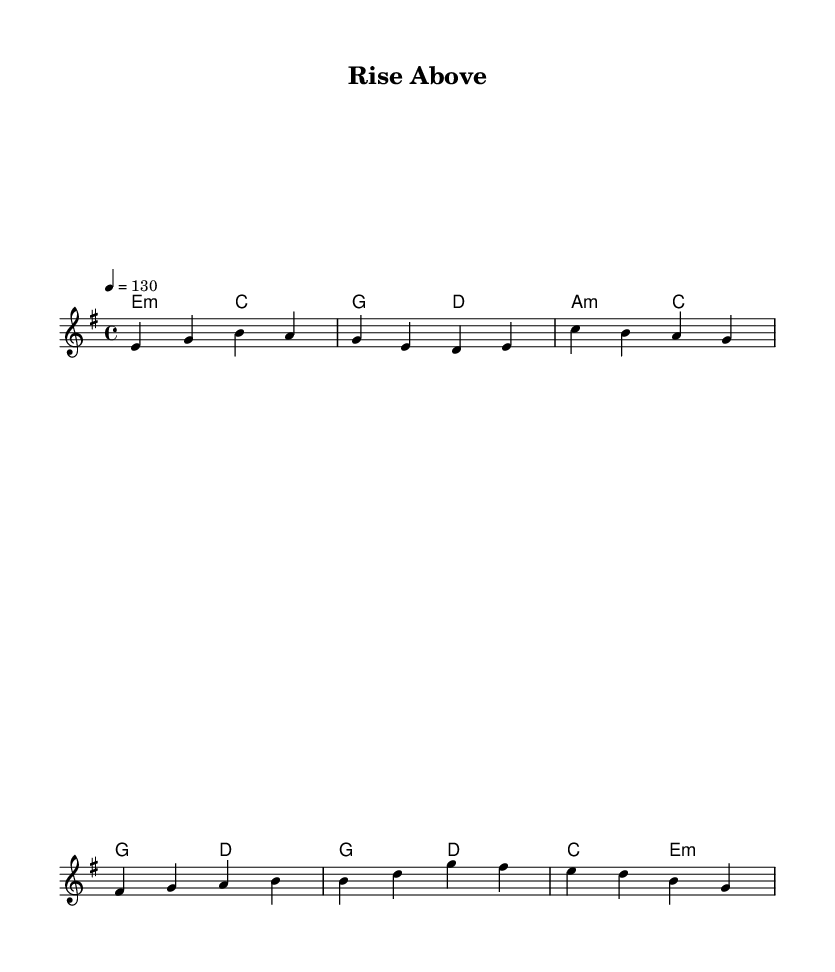What is the key signature of this music? The key signature is indicated by the presence of the E minor key label at the beginning of the score. E minor has one sharp (F#), but it is simply represented as E minor in the context of the piece.
Answer: E minor What is the time signature of this music? The time signature is found at the beginning of the score, indicated by the notation "4/4". This means there are four beats per measure, and each quarter note gets one beat.
Answer: 4/4 What is the tempo marking of this music? The tempo marking appears in the score indicated by "4 = 130", which states that there are 130 beats per minute when counted in quarter notes.
Answer: 130 How many measures are in the verse section? The verse section consists of two lines of lyrics, each with four beats. Each line represents one measure, so the total number of measures can be counted as two.
Answer: 2 What is the primary theme of the chorus? The chorus contains the lyrics "Rise above, believe in yourself," which conveys a message of self-empowerment and perseverance, summing up the overall motivational theme of the song.
Answer: Rise above, believe in yourself What type of chords are mostly used in the harmonies section? The harmonies section includes minor chords, as indicated by the presence of "m" after certain chord symbols, indicating the use of minor triads throughout.
Answer: Minor In what section do we see a change in the lyrical content? The change in lyrical content occurs as the piece transitions from the verse to the pre-chorus. The pre-chorus introduces new lyrics that build anticipation for the chorus.
Answer: From verse to pre-chorus 